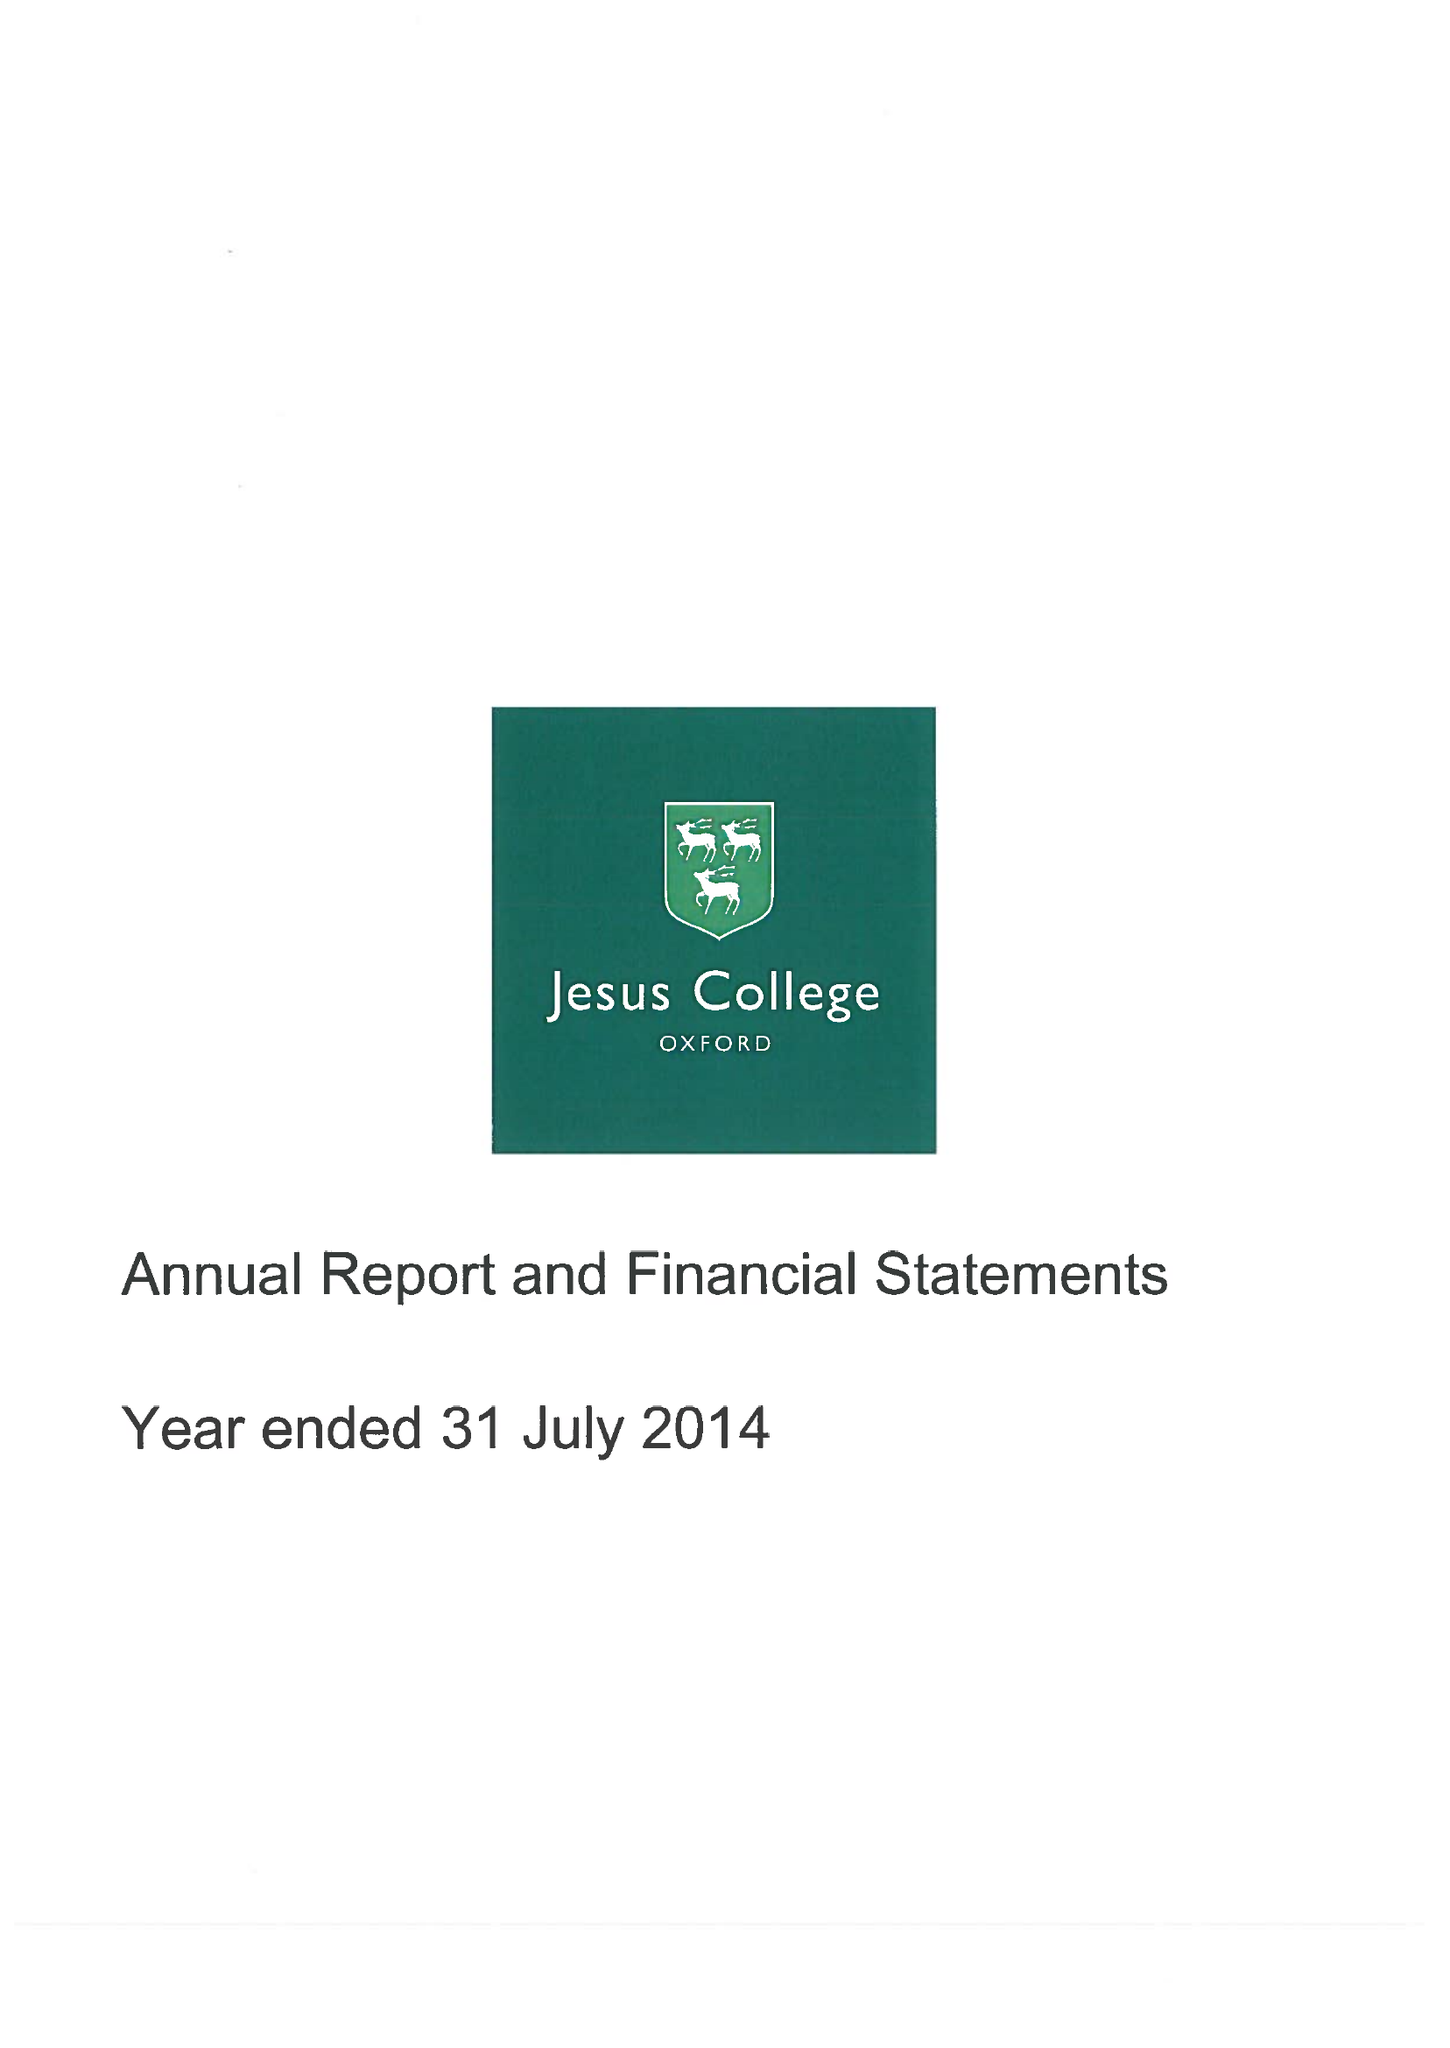What is the value for the report_date?
Answer the question using a single word or phrase. 2014-07-31 